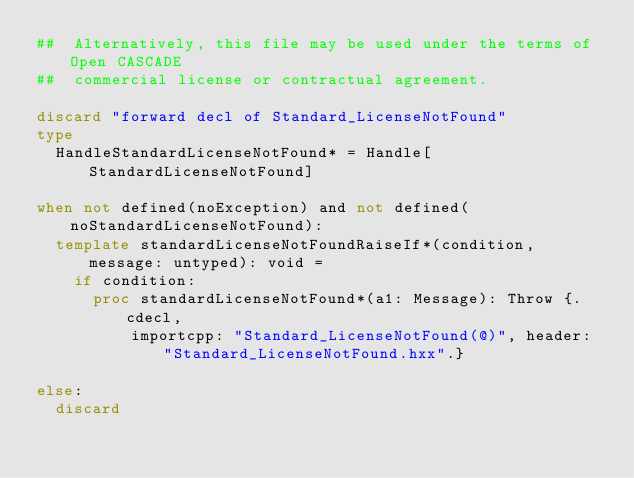Convert code to text. <code><loc_0><loc_0><loc_500><loc_500><_Nim_>##  Alternatively, this file may be used under the terms of Open CASCADE
##  commercial license or contractual agreement.

discard "forward decl of Standard_LicenseNotFound"
type
  HandleStandardLicenseNotFound* = Handle[StandardLicenseNotFound]

when not defined(noException) and not defined(noStandardLicenseNotFound):
  template standardLicenseNotFoundRaiseIf*(condition, message: untyped): void =
    if condition:
      proc standardLicenseNotFound*(a1: Message): Throw {.cdecl,
          importcpp: "Standard_LicenseNotFound(@)", header: "Standard_LicenseNotFound.hxx".}

else:
  discard</code> 